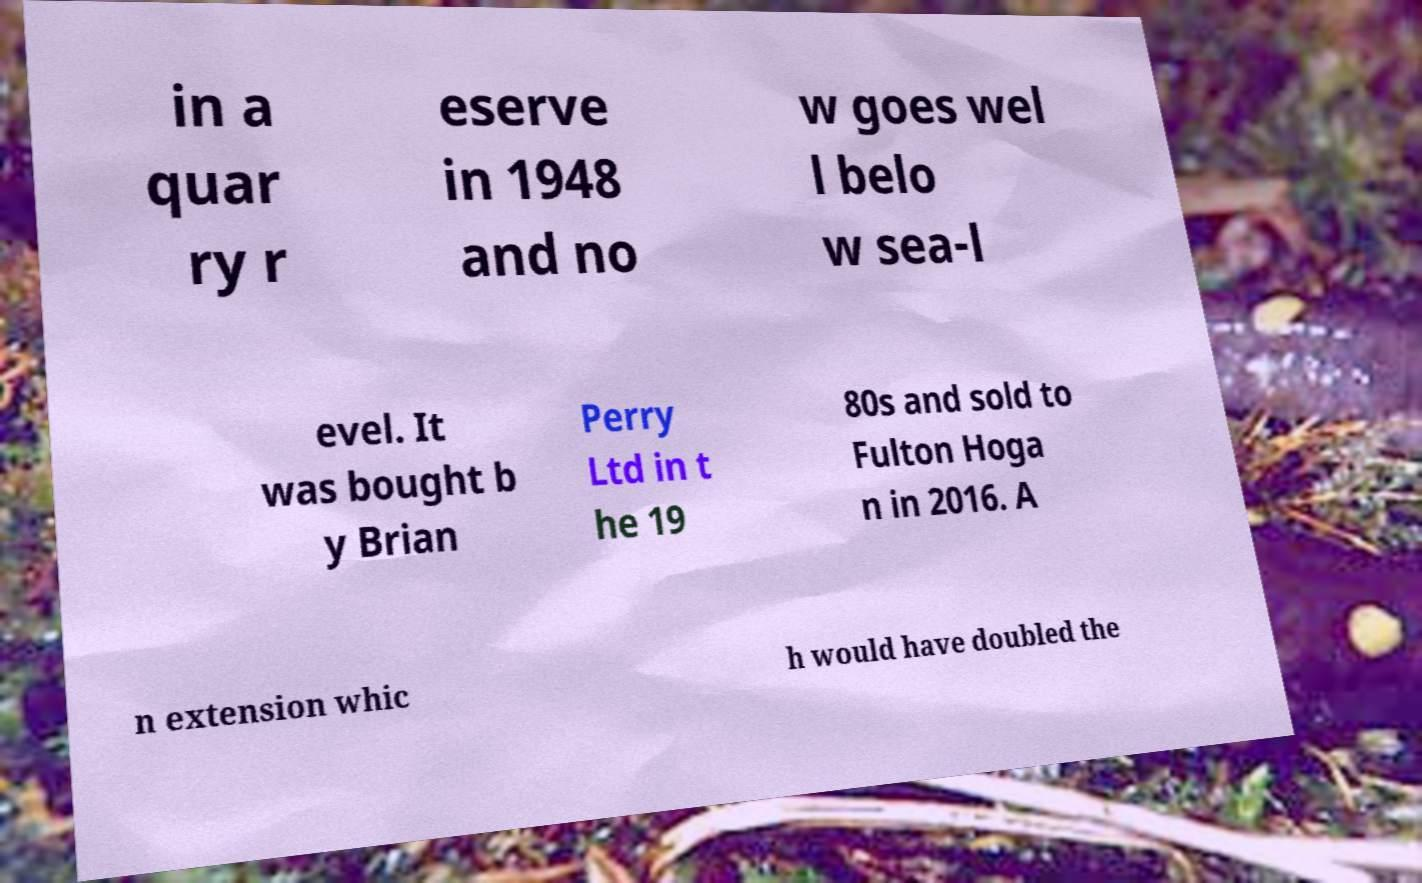Please read and relay the text visible in this image. What does it say? in a quar ry r eserve in 1948 and no w goes wel l belo w sea-l evel. It was bought b y Brian Perry Ltd in t he 19 80s and sold to Fulton Hoga n in 2016. A n extension whic h would have doubled the 